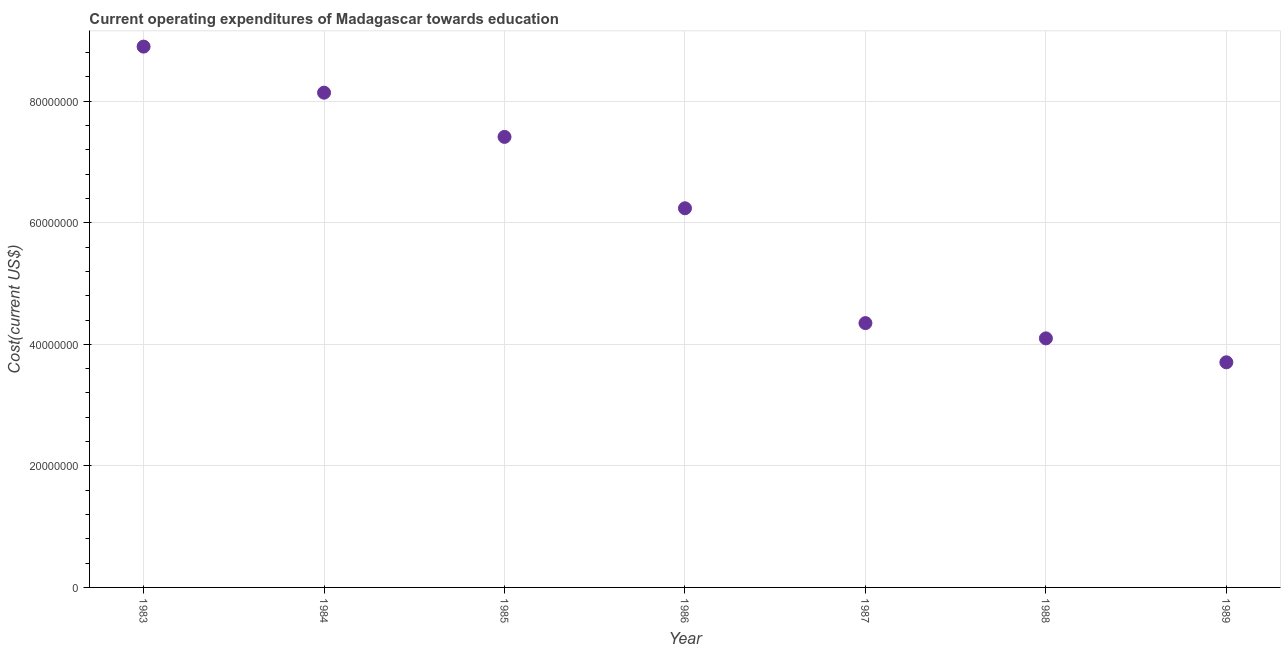What is the education expenditure in 1983?
Your answer should be very brief. 8.90e+07. Across all years, what is the maximum education expenditure?
Provide a short and direct response. 8.90e+07. Across all years, what is the minimum education expenditure?
Provide a short and direct response. 3.70e+07. What is the sum of the education expenditure?
Ensure brevity in your answer.  4.28e+08. What is the difference between the education expenditure in 1987 and 1989?
Make the answer very short. 6.45e+06. What is the average education expenditure per year?
Provide a succinct answer. 6.12e+07. What is the median education expenditure?
Offer a very short reply. 6.24e+07. In how many years, is the education expenditure greater than 4000000 US$?
Offer a terse response. 7. What is the ratio of the education expenditure in 1984 to that in 1988?
Offer a terse response. 1.99. What is the difference between the highest and the second highest education expenditure?
Your response must be concise. 7.58e+06. Is the sum of the education expenditure in 1987 and 1988 greater than the maximum education expenditure across all years?
Provide a short and direct response. No. What is the difference between the highest and the lowest education expenditure?
Your answer should be compact. 5.19e+07. How many years are there in the graph?
Provide a short and direct response. 7. Are the values on the major ticks of Y-axis written in scientific E-notation?
Ensure brevity in your answer.  No. Does the graph contain any zero values?
Offer a terse response. No. What is the title of the graph?
Offer a terse response. Current operating expenditures of Madagascar towards education. What is the label or title of the Y-axis?
Your response must be concise. Cost(current US$). What is the Cost(current US$) in 1983?
Your answer should be compact. 8.90e+07. What is the Cost(current US$) in 1984?
Make the answer very short. 8.14e+07. What is the Cost(current US$) in 1985?
Provide a succinct answer. 7.41e+07. What is the Cost(current US$) in 1986?
Offer a very short reply. 6.24e+07. What is the Cost(current US$) in 1987?
Your answer should be very brief. 4.35e+07. What is the Cost(current US$) in 1988?
Your answer should be very brief. 4.10e+07. What is the Cost(current US$) in 1989?
Give a very brief answer. 3.70e+07. What is the difference between the Cost(current US$) in 1983 and 1984?
Offer a terse response. 7.58e+06. What is the difference between the Cost(current US$) in 1983 and 1985?
Give a very brief answer. 1.49e+07. What is the difference between the Cost(current US$) in 1983 and 1986?
Offer a terse response. 2.66e+07. What is the difference between the Cost(current US$) in 1983 and 1987?
Your answer should be compact. 4.55e+07. What is the difference between the Cost(current US$) in 1983 and 1988?
Your response must be concise. 4.80e+07. What is the difference between the Cost(current US$) in 1983 and 1989?
Ensure brevity in your answer.  5.19e+07. What is the difference between the Cost(current US$) in 1984 and 1985?
Your answer should be very brief. 7.28e+06. What is the difference between the Cost(current US$) in 1984 and 1986?
Keep it short and to the point. 1.90e+07. What is the difference between the Cost(current US$) in 1984 and 1987?
Ensure brevity in your answer.  3.79e+07. What is the difference between the Cost(current US$) in 1984 and 1988?
Your answer should be compact. 4.04e+07. What is the difference between the Cost(current US$) in 1984 and 1989?
Ensure brevity in your answer.  4.44e+07. What is the difference between the Cost(current US$) in 1985 and 1986?
Give a very brief answer. 1.17e+07. What is the difference between the Cost(current US$) in 1985 and 1987?
Your response must be concise. 3.06e+07. What is the difference between the Cost(current US$) in 1985 and 1988?
Your answer should be compact. 3.32e+07. What is the difference between the Cost(current US$) in 1985 and 1989?
Offer a terse response. 3.71e+07. What is the difference between the Cost(current US$) in 1986 and 1987?
Provide a succinct answer. 1.89e+07. What is the difference between the Cost(current US$) in 1986 and 1988?
Your response must be concise. 2.14e+07. What is the difference between the Cost(current US$) in 1986 and 1989?
Ensure brevity in your answer.  2.53e+07. What is the difference between the Cost(current US$) in 1987 and 1988?
Your response must be concise. 2.51e+06. What is the difference between the Cost(current US$) in 1987 and 1989?
Keep it short and to the point. 6.45e+06. What is the difference between the Cost(current US$) in 1988 and 1989?
Provide a succinct answer. 3.94e+06. What is the ratio of the Cost(current US$) in 1983 to that in 1984?
Your answer should be compact. 1.09. What is the ratio of the Cost(current US$) in 1983 to that in 1985?
Keep it short and to the point. 1.2. What is the ratio of the Cost(current US$) in 1983 to that in 1986?
Give a very brief answer. 1.43. What is the ratio of the Cost(current US$) in 1983 to that in 1987?
Provide a short and direct response. 2.05. What is the ratio of the Cost(current US$) in 1983 to that in 1988?
Your answer should be compact. 2.17. What is the ratio of the Cost(current US$) in 1983 to that in 1989?
Give a very brief answer. 2.4. What is the ratio of the Cost(current US$) in 1984 to that in 1985?
Offer a very short reply. 1.1. What is the ratio of the Cost(current US$) in 1984 to that in 1986?
Provide a short and direct response. 1.3. What is the ratio of the Cost(current US$) in 1984 to that in 1987?
Your answer should be compact. 1.87. What is the ratio of the Cost(current US$) in 1984 to that in 1988?
Your answer should be compact. 1.99. What is the ratio of the Cost(current US$) in 1984 to that in 1989?
Make the answer very short. 2.2. What is the ratio of the Cost(current US$) in 1985 to that in 1986?
Keep it short and to the point. 1.19. What is the ratio of the Cost(current US$) in 1985 to that in 1987?
Keep it short and to the point. 1.7. What is the ratio of the Cost(current US$) in 1985 to that in 1988?
Give a very brief answer. 1.81. What is the ratio of the Cost(current US$) in 1985 to that in 1989?
Offer a very short reply. 2. What is the ratio of the Cost(current US$) in 1986 to that in 1987?
Your answer should be very brief. 1.43. What is the ratio of the Cost(current US$) in 1986 to that in 1988?
Offer a very short reply. 1.52. What is the ratio of the Cost(current US$) in 1986 to that in 1989?
Your answer should be compact. 1.68. What is the ratio of the Cost(current US$) in 1987 to that in 1988?
Ensure brevity in your answer.  1.06. What is the ratio of the Cost(current US$) in 1987 to that in 1989?
Make the answer very short. 1.17. What is the ratio of the Cost(current US$) in 1988 to that in 1989?
Offer a very short reply. 1.11. 